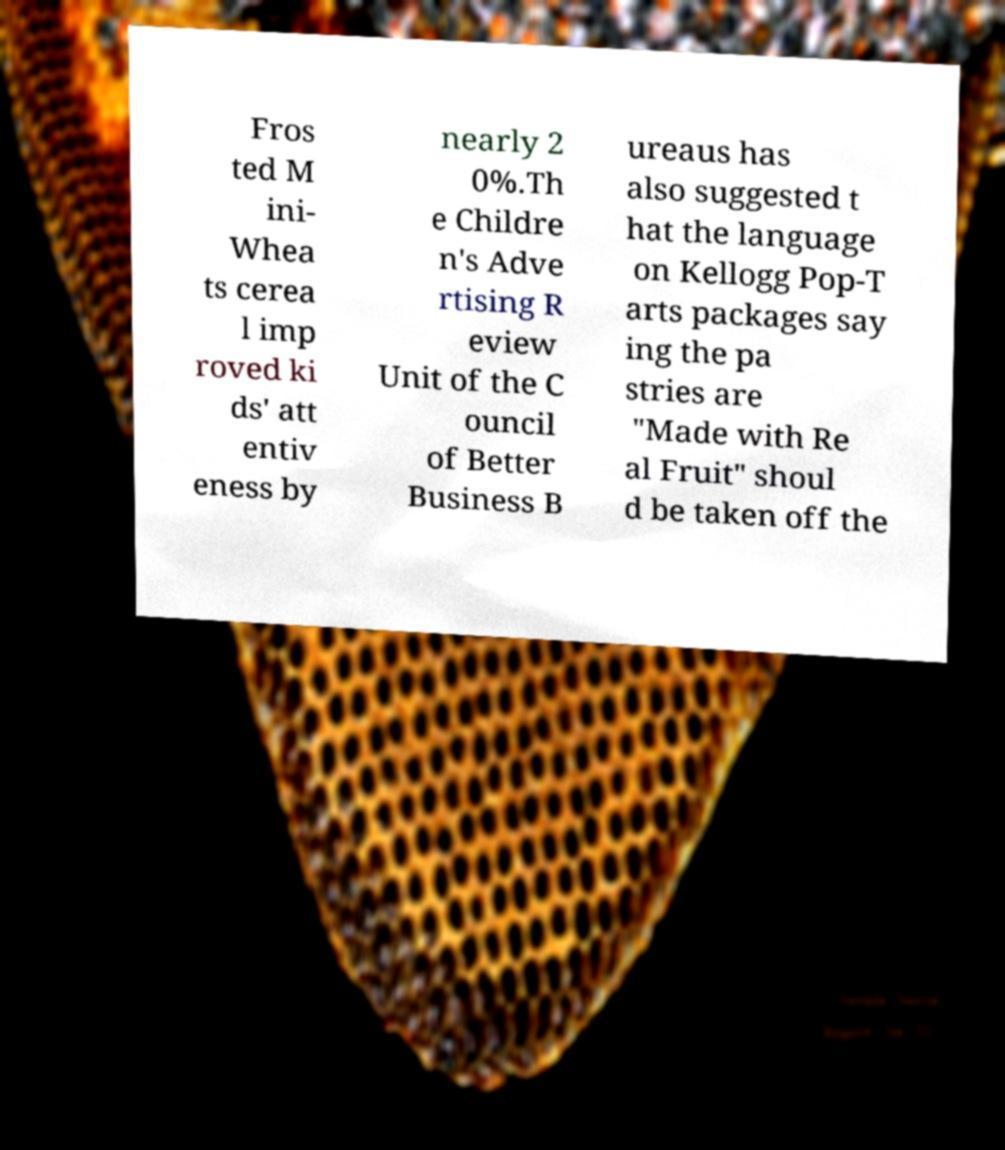There's text embedded in this image that I need extracted. Can you transcribe it verbatim? Fros ted M ini- Whea ts cerea l imp roved ki ds' att entiv eness by nearly 2 0%.Th e Childre n's Adve rtising R eview Unit of the C ouncil of Better Business B ureaus has also suggested t hat the language on Kellogg Pop-T arts packages say ing the pa stries are "Made with Re al Fruit" shoul d be taken off the 